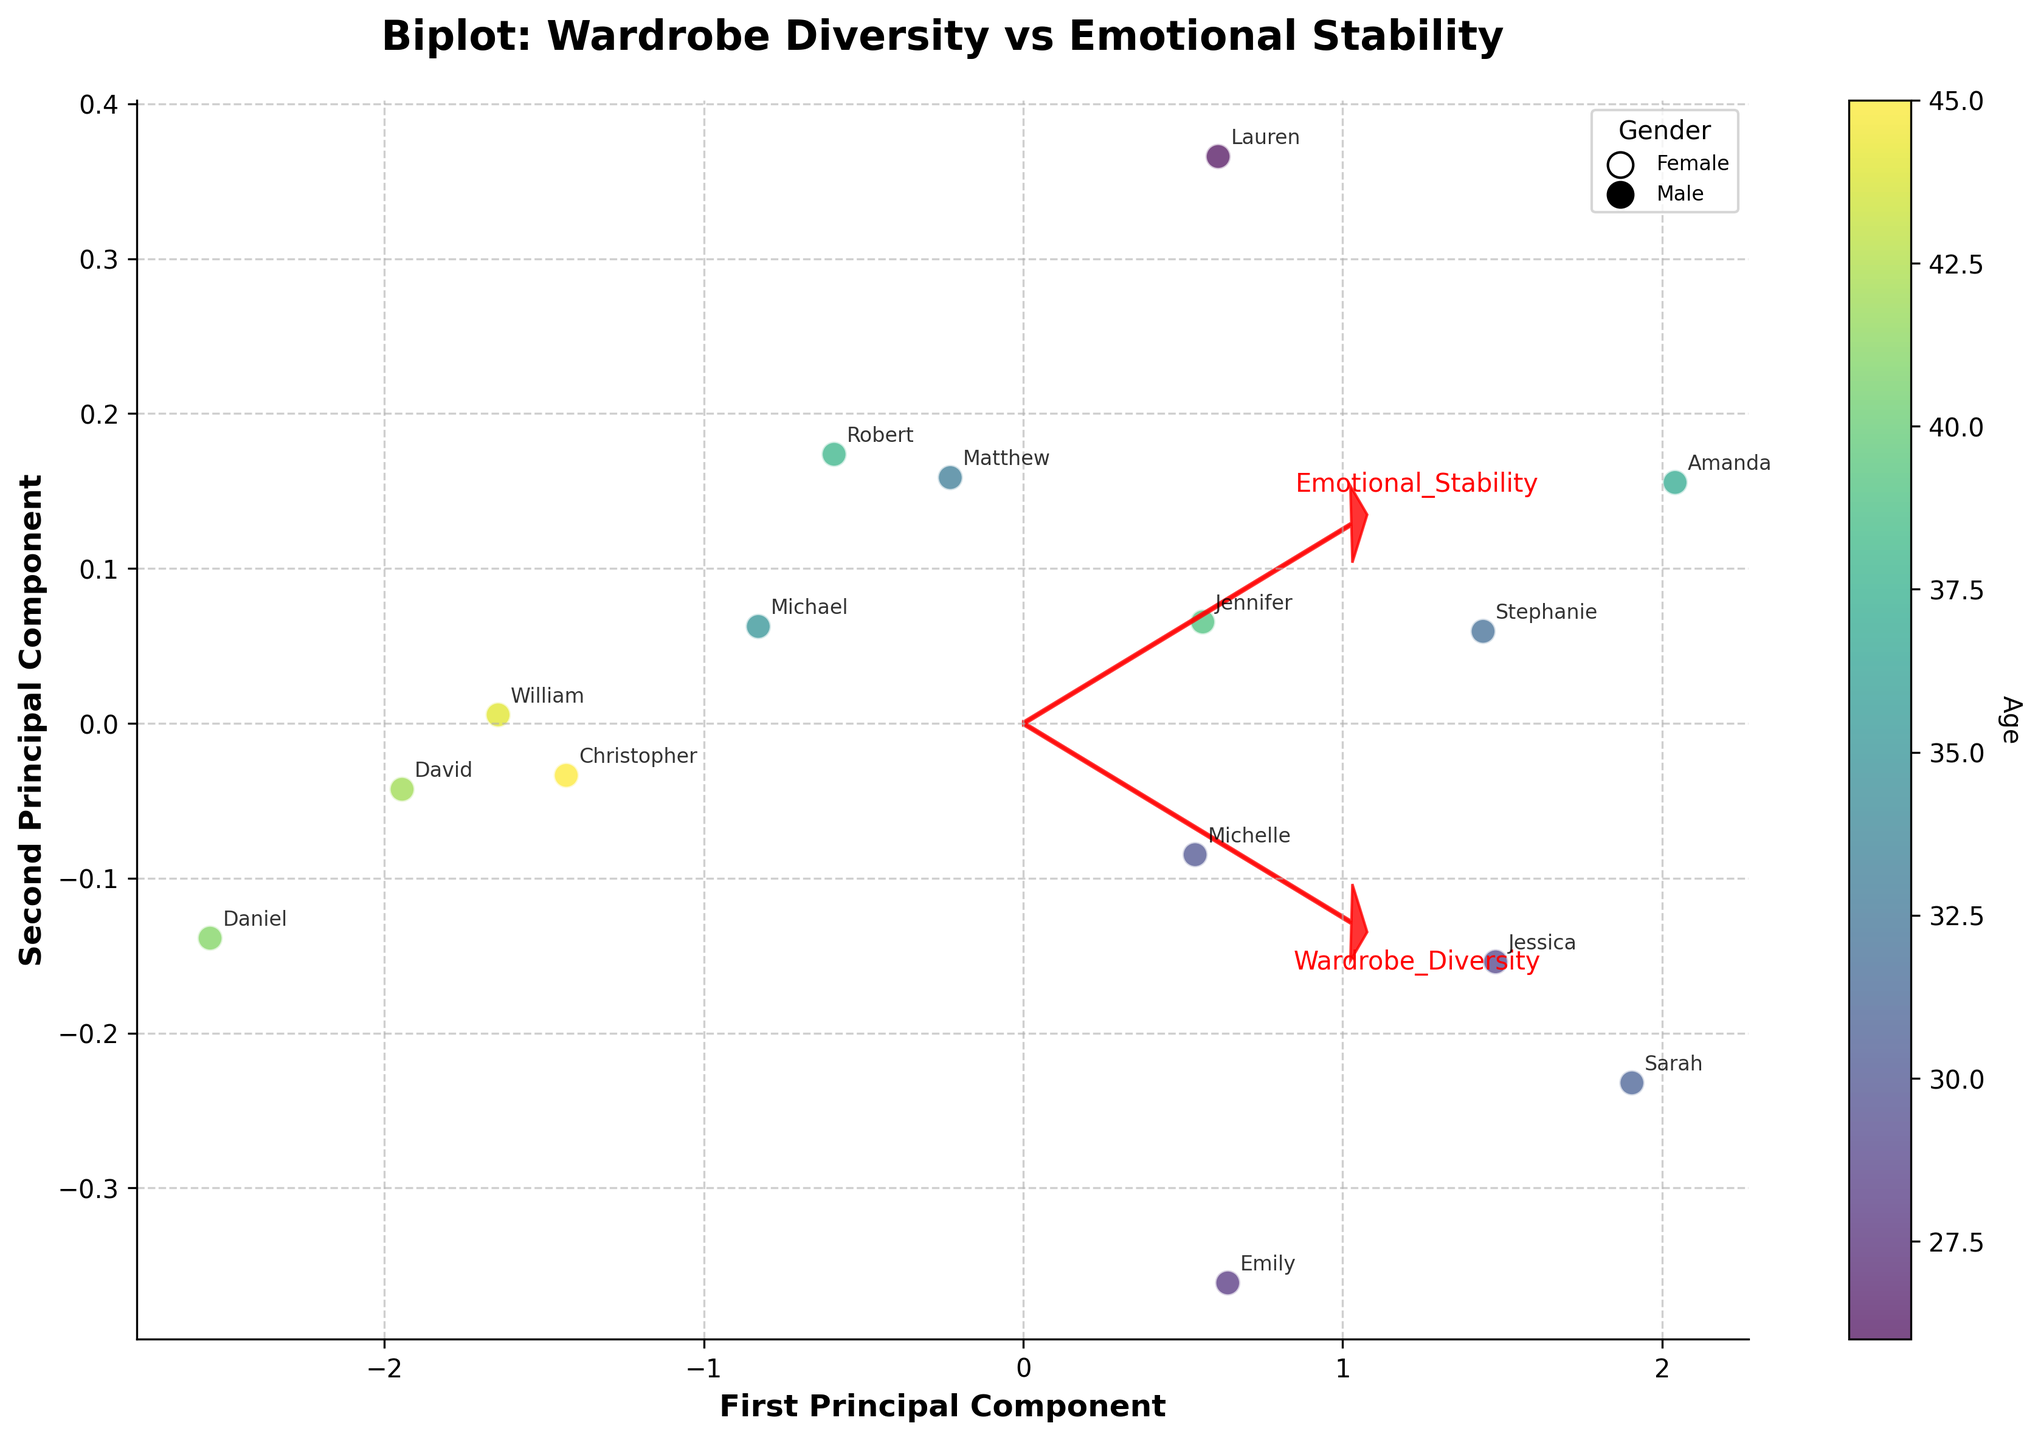Which direction does the arrow for "Wardrobe Diversity" point? The arrow for "Wardrobe Diversity" points right and slightly upward from the origin, as indicated by the red arrow.
Answer: Right and slightly upward How many principal components are displayed on the biplot? The biplot displays two principal components as indicated by the x-axis and y-axis labeled "First Principal Component" and "Second Principal Component."
Answer: Two What's the relationship between the age and the color of the data points? The data points are colored in a gradient where younger ages correspond to lighter colors and older ages to darker colors, as indicated by the colorbar labeled "Age."
Answer: Lighter colors for younger, darker for older Which participant appears closest to the origin? By examining the annotated points on the biplot, Christopher_Anderson seems to be closest to the origin among the participants.
Answer: Christopher Which gender is more represented in the top-right quadrant of the biplot? Referring to the annotated gender information in the legend combined with the participant labeling, females appear more frequently in the top-right quadrant of the biplot.
Answer: Females Which variable has a stronger influence on the first principal component? The direction and length of the arrows indicate the influence, and the arrow for "Wardrobe Diversity" is more aligned with the x-axis (First Principal Component) compared to "Emotional Stability."
Answer: Wardrobe Diversity Who are the oldest and youngest participants, and where are they located on the biplot? The color coding and annotations show that William_Young and Michelle_Lee (darkest and one of the lighter points respectively) appear on the left and bottom of the biplot.
Answer: William (left) and Michelle (bottom) How do Emily_Johnson's wardrobe diversity and emotional stability scores compare to the average scores? Emily_Johnson's scores are relatively high for both variables. On the biplot, her position is towards the right-middle, and the average point would be near the center, indicating her scores are above average.
Answer: Above average Are there any participants whose scores on both variables are below average? The below-average area for both Wardrobe Diversity and Emotional Stability would be in the bottom-left quadrant of the biplot. Reviewing this section, no participant is explicitly labeled there, suggesting none have below-average scores in both.
Answer: No Which principal component captures more variance in the data? The answer is inferred from the labeled axes; the first principal component often captures more variance, followed by the second.
Answer: First Principal Component 